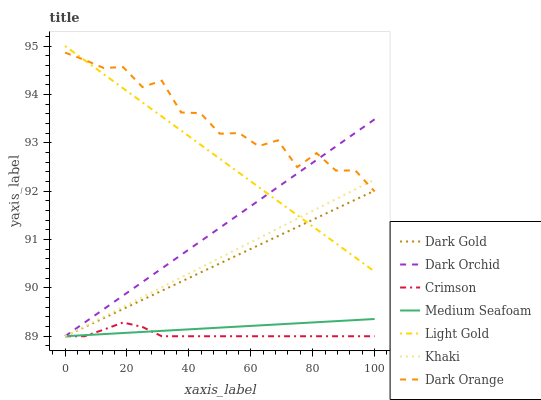Does Crimson have the minimum area under the curve?
Answer yes or no. Yes. Does Dark Orange have the maximum area under the curve?
Answer yes or no. Yes. Does Khaki have the minimum area under the curve?
Answer yes or no. No. Does Khaki have the maximum area under the curve?
Answer yes or no. No. Is Khaki the smoothest?
Answer yes or no. Yes. Is Dark Orange the roughest?
Answer yes or no. Yes. Is Dark Gold the smoothest?
Answer yes or no. No. Is Dark Gold the roughest?
Answer yes or no. No. Does Khaki have the lowest value?
Answer yes or no. Yes. Does Light Gold have the lowest value?
Answer yes or no. No. Does Light Gold have the highest value?
Answer yes or no. Yes. Does Khaki have the highest value?
Answer yes or no. No. Is Medium Seafoam less than Dark Orange?
Answer yes or no. Yes. Is Light Gold greater than Crimson?
Answer yes or no. Yes. Does Dark Gold intersect Crimson?
Answer yes or no. Yes. Is Dark Gold less than Crimson?
Answer yes or no. No. Is Dark Gold greater than Crimson?
Answer yes or no. No. Does Medium Seafoam intersect Dark Orange?
Answer yes or no. No. 